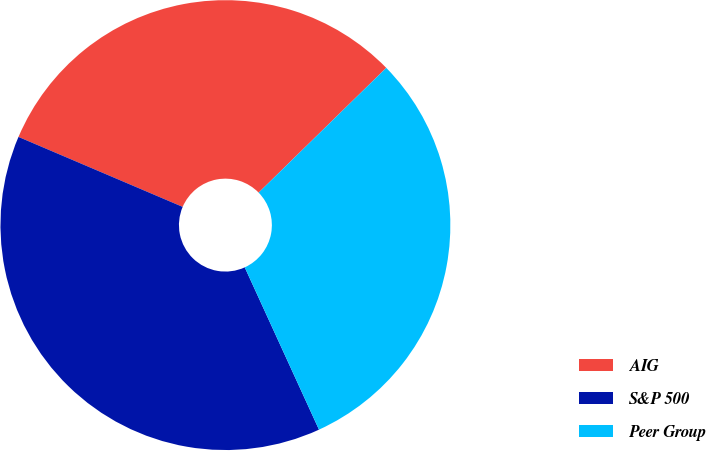Convert chart to OTSL. <chart><loc_0><loc_0><loc_500><loc_500><pie_chart><fcel>AIG<fcel>S&P 500<fcel>Peer Group<nl><fcel>31.27%<fcel>38.24%<fcel>30.49%<nl></chart> 